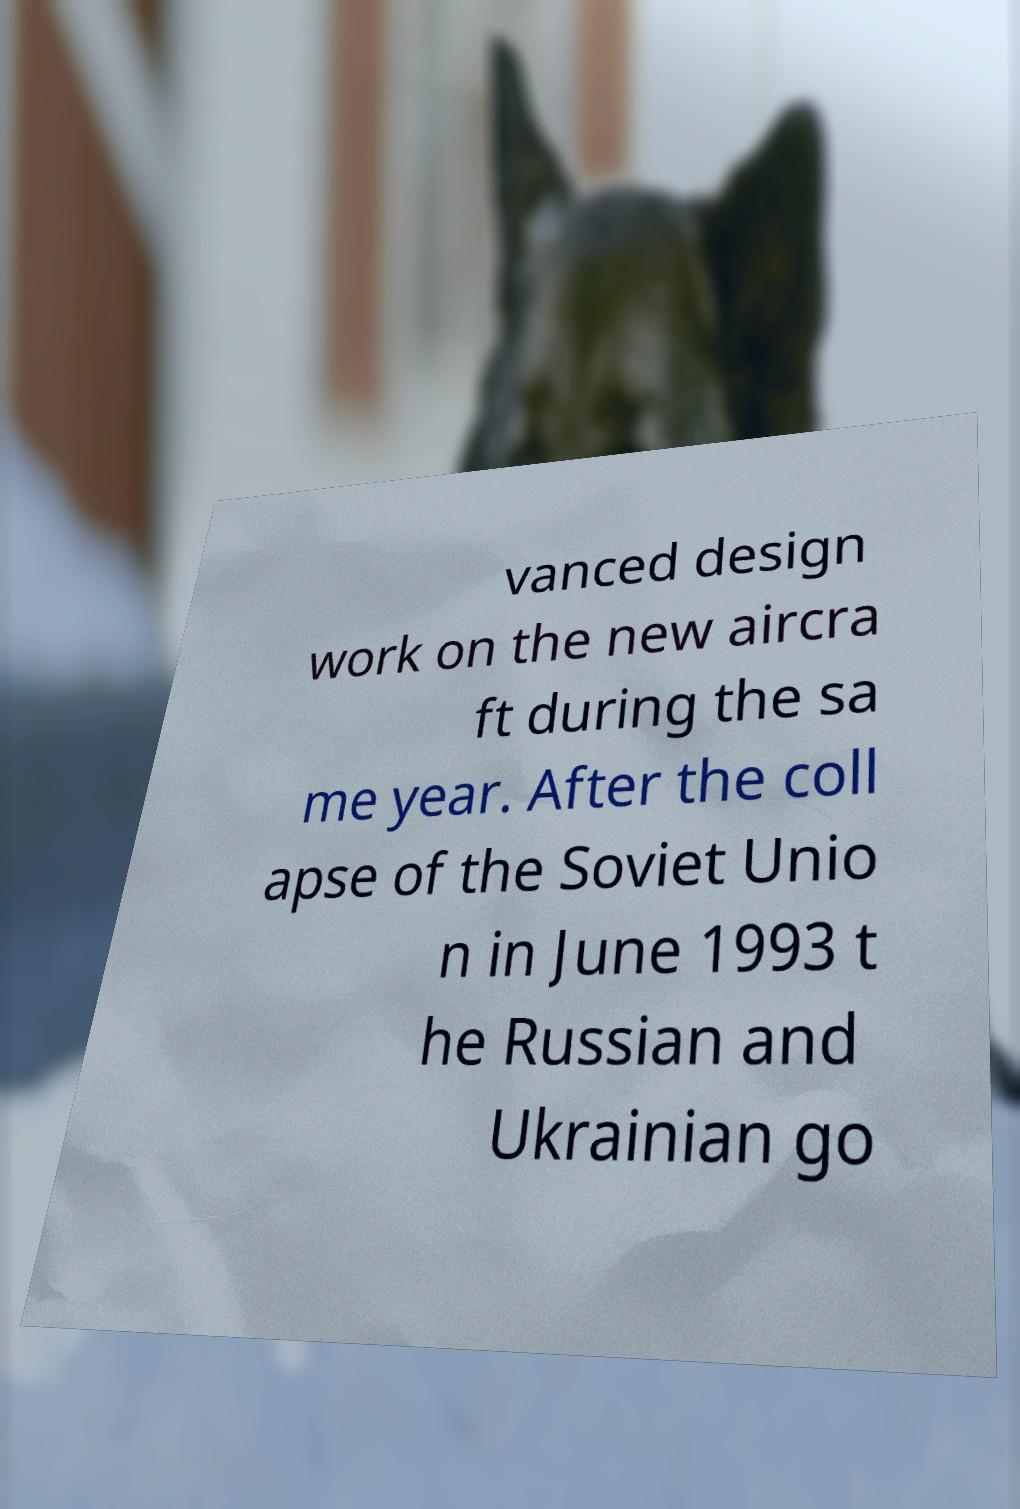I need the written content from this picture converted into text. Can you do that? vanced design work on the new aircra ft during the sa me year. After the coll apse of the Soviet Unio n in June 1993 t he Russian and Ukrainian go 